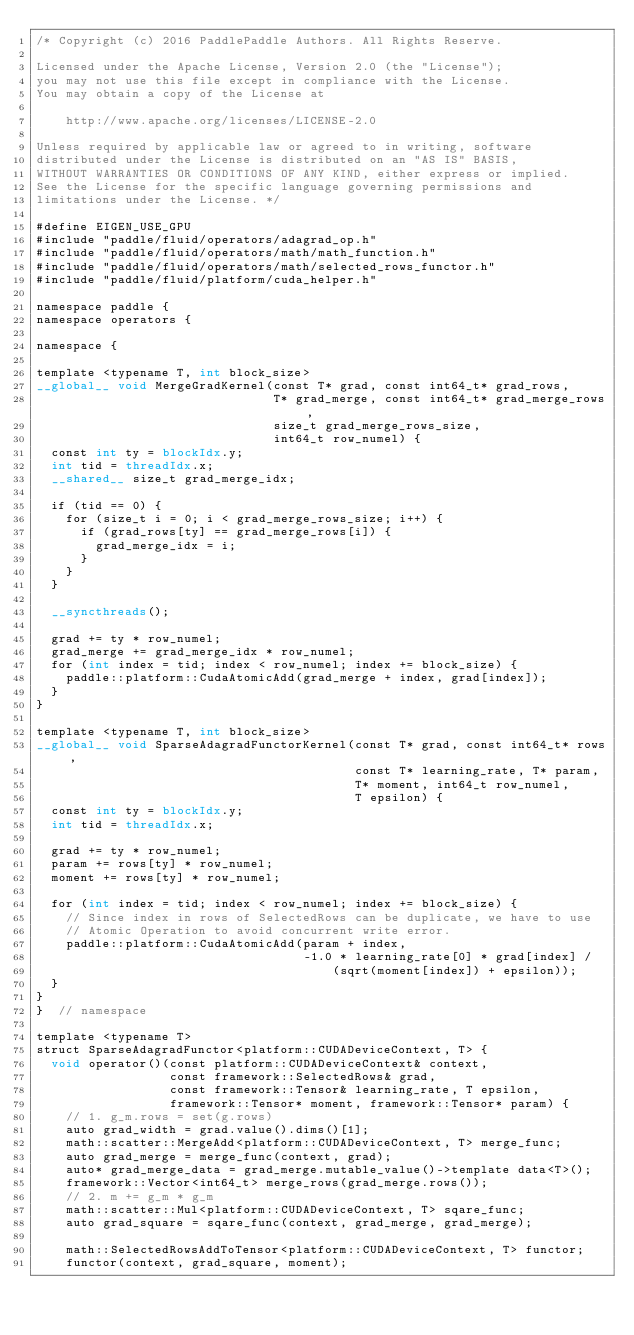<code> <loc_0><loc_0><loc_500><loc_500><_Cuda_>/* Copyright (c) 2016 PaddlePaddle Authors. All Rights Reserve.

Licensed under the Apache License, Version 2.0 (the "License");
you may not use this file except in compliance with the License.
You may obtain a copy of the License at

    http://www.apache.org/licenses/LICENSE-2.0

Unless required by applicable law or agreed to in writing, software
distributed under the License is distributed on an "AS IS" BASIS,
WITHOUT WARRANTIES OR CONDITIONS OF ANY KIND, either express or implied.
See the License for the specific language governing permissions and
limitations under the License. */

#define EIGEN_USE_GPU
#include "paddle/fluid/operators/adagrad_op.h"
#include "paddle/fluid/operators/math/math_function.h"
#include "paddle/fluid/operators/math/selected_rows_functor.h"
#include "paddle/fluid/platform/cuda_helper.h"

namespace paddle {
namespace operators {

namespace {

template <typename T, int block_size>
__global__ void MergeGradKernel(const T* grad, const int64_t* grad_rows,
                                T* grad_merge, const int64_t* grad_merge_rows,
                                size_t grad_merge_rows_size,
                                int64_t row_numel) {
  const int ty = blockIdx.y;
  int tid = threadIdx.x;
  __shared__ size_t grad_merge_idx;

  if (tid == 0) {
    for (size_t i = 0; i < grad_merge_rows_size; i++) {
      if (grad_rows[ty] == grad_merge_rows[i]) {
        grad_merge_idx = i;
      }
    }
  }

  __syncthreads();

  grad += ty * row_numel;
  grad_merge += grad_merge_idx * row_numel;
  for (int index = tid; index < row_numel; index += block_size) {
    paddle::platform::CudaAtomicAdd(grad_merge + index, grad[index]);
  }
}

template <typename T, int block_size>
__global__ void SparseAdagradFunctorKernel(const T* grad, const int64_t* rows,
                                           const T* learning_rate, T* param,
                                           T* moment, int64_t row_numel,
                                           T epsilon) {
  const int ty = blockIdx.y;
  int tid = threadIdx.x;

  grad += ty * row_numel;
  param += rows[ty] * row_numel;
  moment += rows[ty] * row_numel;

  for (int index = tid; index < row_numel; index += block_size) {
    // Since index in rows of SelectedRows can be duplicate, we have to use
    // Atomic Operation to avoid concurrent write error.
    paddle::platform::CudaAtomicAdd(param + index,
                                    -1.0 * learning_rate[0] * grad[index] /
                                        (sqrt(moment[index]) + epsilon));
  }
}
}  // namespace

template <typename T>
struct SparseAdagradFunctor<platform::CUDADeviceContext, T> {
  void operator()(const platform::CUDADeviceContext& context,
                  const framework::SelectedRows& grad,
                  const framework::Tensor& learning_rate, T epsilon,
                  framework::Tensor* moment, framework::Tensor* param) {
    // 1. g_m.rows = set(g.rows)
    auto grad_width = grad.value().dims()[1];
    math::scatter::MergeAdd<platform::CUDADeviceContext, T> merge_func;
    auto grad_merge = merge_func(context, grad);
    auto* grad_merge_data = grad_merge.mutable_value()->template data<T>();
    framework::Vector<int64_t> merge_rows(grad_merge.rows());
    // 2. m += g_m * g_m
    math::scatter::Mul<platform::CUDADeviceContext, T> sqare_func;
    auto grad_square = sqare_func(context, grad_merge, grad_merge);

    math::SelectedRowsAddToTensor<platform::CUDADeviceContext, T> functor;
    functor(context, grad_square, moment);
</code> 